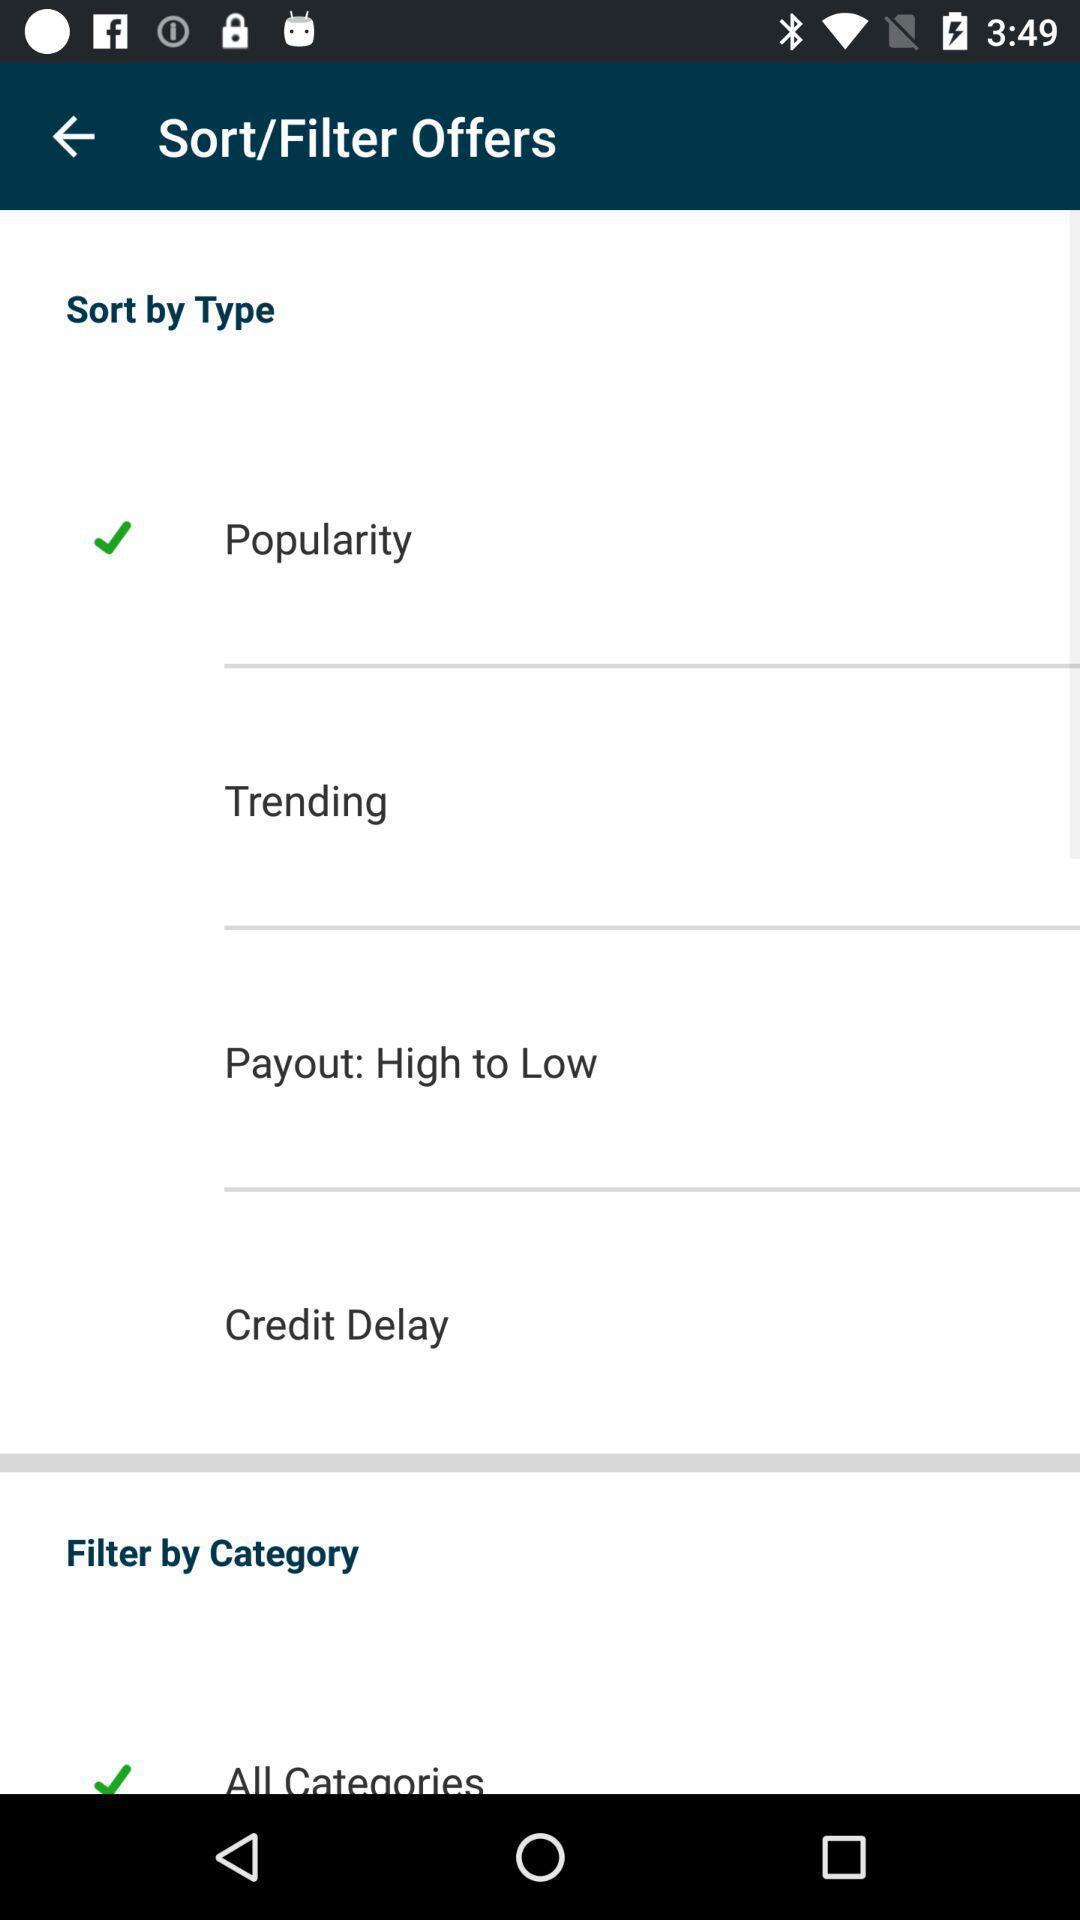Provide a description of this screenshot. Sort and filter page of an online shopping app. 